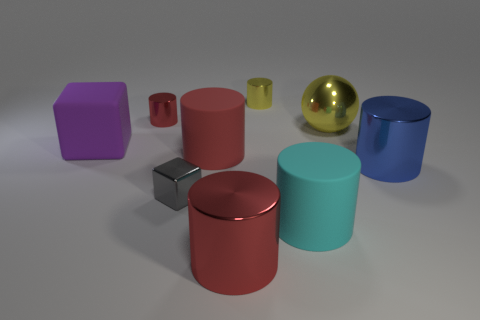There is a shiny cylinder that is both to the right of the small red object and behind the large metallic sphere; how big is it?
Your response must be concise. Small. How many blue shiny things are the same size as the blue cylinder?
Provide a short and direct response. 0. How many rubber things are either small cyan objects or blue things?
Offer a terse response. 0. There is a shiny object that is the same color as the large metal ball; what is its size?
Your answer should be compact. Small. There is a big object left of the big matte cylinder to the left of the yellow metal cylinder; what is it made of?
Provide a succinct answer. Rubber. How many objects are either big yellow cylinders or yellow metal things behind the yellow metal sphere?
Your answer should be very brief. 1. There is a red object that is the same material as the large purple object; what size is it?
Offer a very short reply. Large. What number of brown objects are shiny blocks or small metal cylinders?
Your answer should be compact. 0. There is a small metal thing that is the same color as the big metallic ball; what is its shape?
Offer a terse response. Cylinder. Is there any other thing that has the same material as the blue cylinder?
Make the answer very short. Yes. 